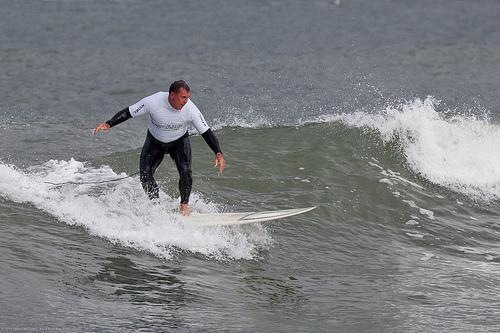Question: when was the photo taken?
Choices:
A. During the summer.
B. Day time.
C. Night time.
D. When the sun came out.
Answer with the letter. Answer: B Question: what is the man doing?
Choices:
A. Fishing.
B. Surfing.
C. Riding a bicycle.
D. Swimming.
Answer with the letter. Answer: B Question: where was the photo taken?
Choices:
A. At the park.
B. At the hotel.
C. In water.
D. At the room.
Answer with the letter. Answer: C 